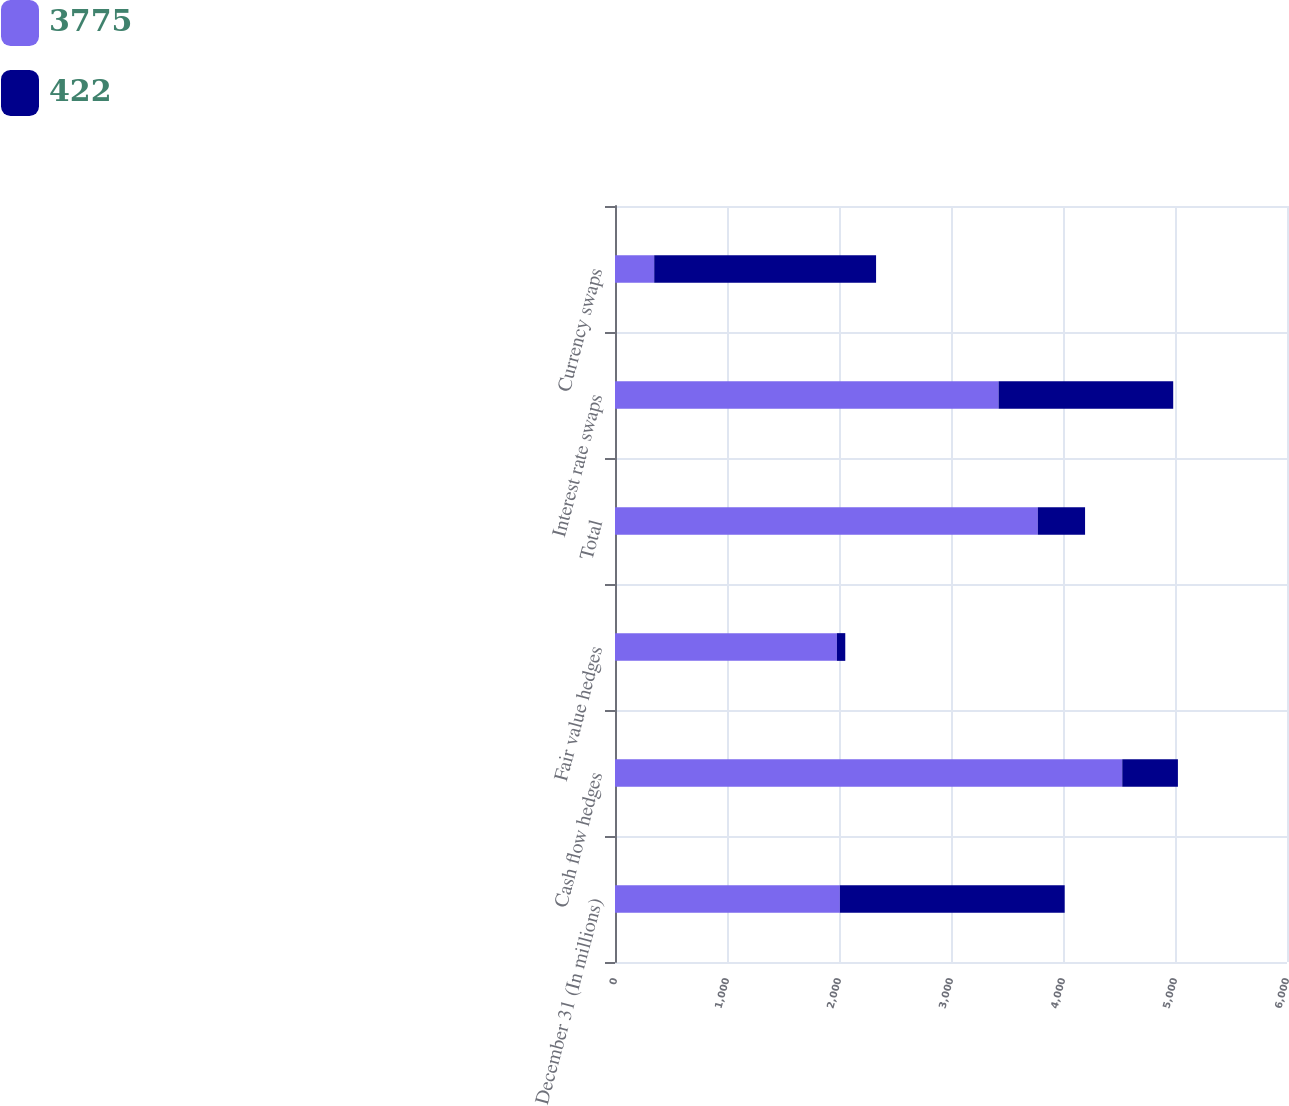<chart> <loc_0><loc_0><loc_500><loc_500><stacked_bar_chart><ecel><fcel>December 31 (In millions)<fcel>Cash flow hedges<fcel>Fair value hedges<fcel>Total<fcel>Interest rate swaps<fcel>Currency swaps<nl><fcel>3775<fcel>2008<fcel>4529<fcel>1981<fcel>3775<fcel>3425<fcel>350<nl><fcel>422<fcel>2007<fcel>497<fcel>75<fcel>422<fcel>1559<fcel>1981<nl></chart> 